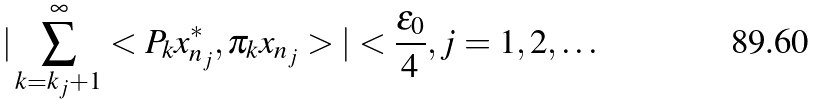<formula> <loc_0><loc_0><loc_500><loc_500>| \sum _ { k = k _ { j } + 1 } ^ { \infty } < P _ { k } x ^ { * } _ { n _ { j } } , \pi _ { k } x _ { n _ { j } } > | < \frac { \epsilon _ { 0 } } { 4 } , j = 1 , 2 , \dots</formula> 